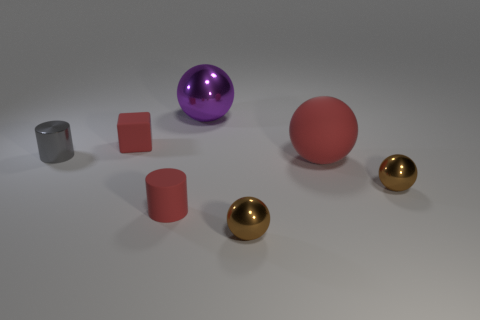Subtract all big purple metal spheres. How many spheres are left? 3 Add 1 red cylinders. How many objects exist? 8 Subtract all purple spheres. How many spheres are left? 3 Subtract all spheres. How many objects are left? 3 Subtract 0 brown cylinders. How many objects are left? 7 Subtract 2 balls. How many balls are left? 2 Subtract all gray cylinders. Subtract all green balls. How many cylinders are left? 1 Subtract all green blocks. How many gray cylinders are left? 1 Subtract all big red matte cylinders. Subtract all red cubes. How many objects are left? 6 Add 2 gray metal things. How many gray metal things are left? 3 